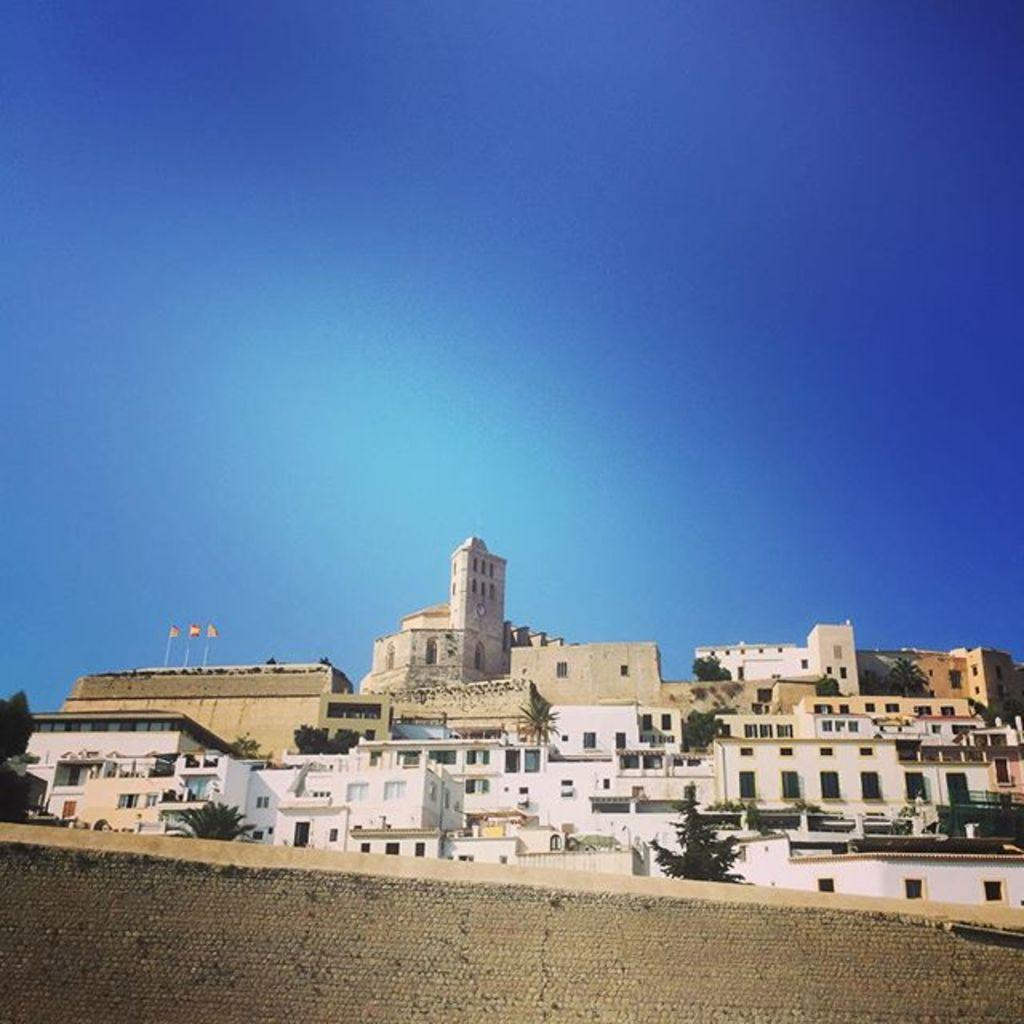What type of structures can be seen in the image? There are buildings in the image. What other natural elements are present in the image? There are trees in the image. Are there any symbols or markers visible in the image? Yes, there are flags in the image. What can be seen in the distance in the image? The sky is visible in the background of the image. What type of zipper can be seen on the trees in the image? There are no zippers present on the trees in the image. How many stamps are visible on the flags in the image? There are no stamps visible on the flags in the image. 